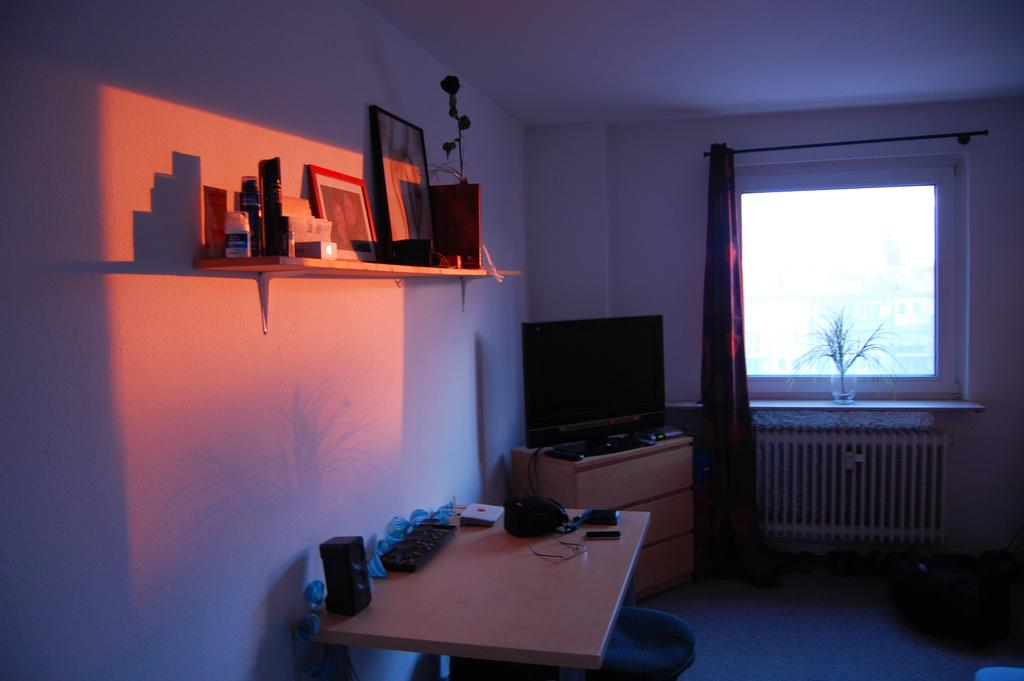What piece of furniture can be found in the room? There is a table in the room. What is placed on the table? There are objects on the table. What feature of the room allows natural light to enter? There is a window in the room. What type of window treatment is present? There is a curtain associated with the window. What type of living organism can be found in the room? There is a plant in the room. What electronic device is located at the back of the room? There is a monitor at the back of the room. What type of storage furniture is in the room? There is a shelf in the room. What type of decorative items can be found on the shelf? There are photo frames on the shelf. What other objects are on the shelf? There are other objects on the shelf. How many lizards are crawling on the monitor in the image? There are no lizards present in the image. What type of cave is visible in the background of the image? There is no cave present in the image. 